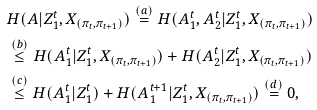<formula> <loc_0><loc_0><loc_500><loc_500>& H ( A | Z ^ { t } _ { 1 } , X _ { ( \pi _ { t } , \pi _ { t + 1 } ) } ) \overset { ( a ) } { = } H ( A ^ { t } _ { 1 } , A ^ { t } _ { 2 } | Z ^ { t } _ { 1 } , X _ { ( \pi _ { t } , \pi _ { t + 1 } ) } ) \\ & \overset { ( b ) } { \leq } H ( A ^ { t } _ { 1 } | Z ^ { t } _ { 1 } , X _ { ( \pi _ { t } , \pi _ { t + 1 } ) } ) + H ( A ^ { t } _ { 2 } | Z ^ { t } _ { 1 } , X _ { ( \pi _ { t } , \pi _ { t + 1 } ) } ) \\ & \overset { ( c ) } { \leq } H ( A ^ { t } _ { 1 } | Z ^ { t } _ { 1 } ) + H ( A ^ { t + 1 } _ { 1 } | Z ^ { t } _ { 1 } , X _ { ( \pi _ { t } , \pi _ { t + 1 } ) } ) \overset { ( d ) } { = } 0 ,</formula> 